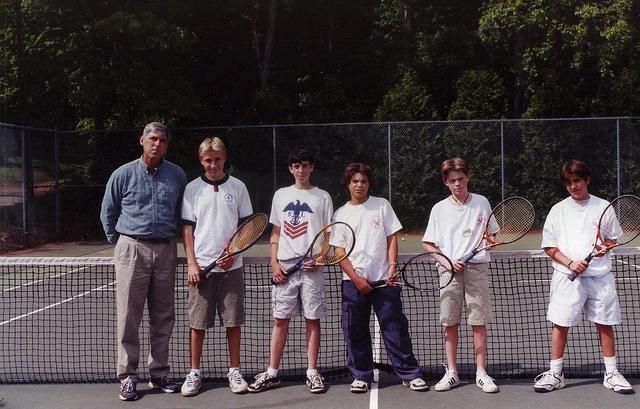How many people can be seen?
Give a very brief answer. 6. 